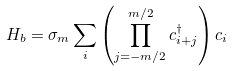<formula> <loc_0><loc_0><loc_500><loc_500>H _ { b } = \sigma _ { m } \sum _ { i } \left ( \prod _ { j = - m / 2 } ^ { m / 2 } c ^ { \dag } _ { i + j } \right ) c _ { i }</formula> 